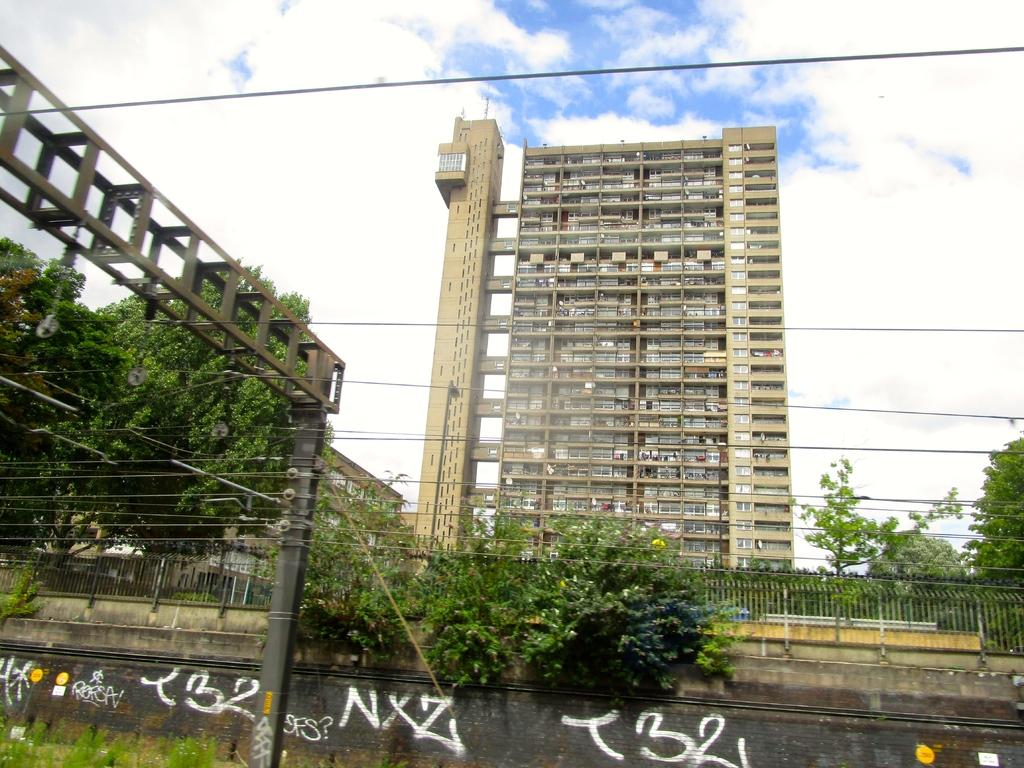What type of structure can be seen in the image? There is a fence in the image, along with poles, wires, and metal rods. What else can be seen in the image besides the fence and related structures? There are trees, buildings, and the sky visible in the image. Can you describe the time of day when the image was likely taken? The image was likely taken during the day, as the sky is visible. How many wings can be seen on the fence in the image? There are no wings present in the image, as the fence is a stationary structure made of metal rods and wires. 